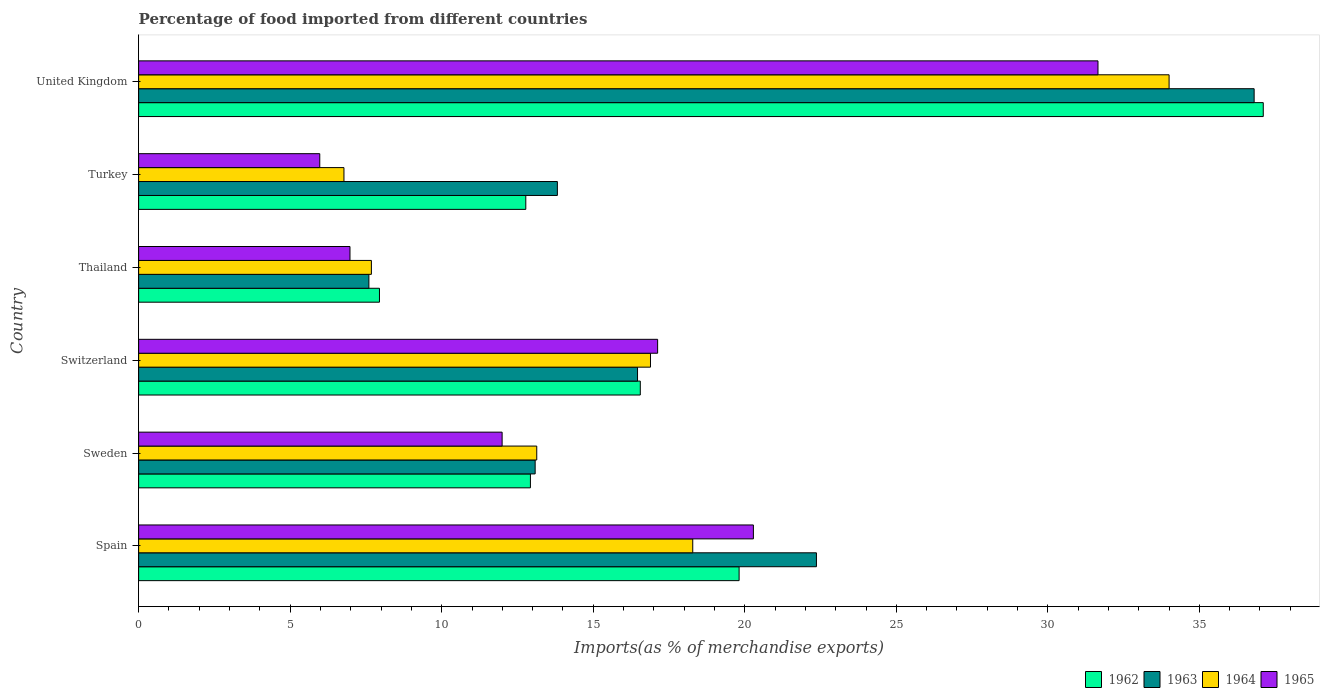How many groups of bars are there?
Your answer should be very brief. 6. Are the number of bars per tick equal to the number of legend labels?
Provide a short and direct response. Yes. Are the number of bars on each tick of the Y-axis equal?
Give a very brief answer. Yes. How many bars are there on the 1st tick from the top?
Give a very brief answer. 4. How many bars are there on the 5th tick from the bottom?
Ensure brevity in your answer.  4. What is the label of the 4th group of bars from the top?
Keep it short and to the point. Switzerland. What is the percentage of imports to different countries in 1962 in Switzerland?
Offer a terse response. 16.55. Across all countries, what is the maximum percentage of imports to different countries in 1962?
Provide a short and direct response. 37.11. Across all countries, what is the minimum percentage of imports to different countries in 1965?
Your answer should be very brief. 5.98. In which country was the percentage of imports to different countries in 1962 minimum?
Your answer should be compact. Thailand. What is the total percentage of imports to different countries in 1964 in the graph?
Offer a terse response. 96.76. What is the difference between the percentage of imports to different countries in 1964 in Switzerland and that in Thailand?
Your response must be concise. 9.21. What is the difference between the percentage of imports to different countries in 1964 in Sweden and the percentage of imports to different countries in 1963 in Spain?
Offer a terse response. -9.23. What is the average percentage of imports to different countries in 1964 per country?
Your answer should be very brief. 16.13. What is the difference between the percentage of imports to different countries in 1965 and percentage of imports to different countries in 1964 in Spain?
Offer a terse response. 2. In how many countries, is the percentage of imports to different countries in 1965 greater than 3 %?
Your response must be concise. 6. What is the ratio of the percentage of imports to different countries in 1962 in Switzerland to that in United Kingdom?
Make the answer very short. 0.45. Is the percentage of imports to different countries in 1963 in Thailand less than that in Turkey?
Give a very brief answer. Yes. What is the difference between the highest and the second highest percentage of imports to different countries in 1963?
Offer a terse response. 14.44. What is the difference between the highest and the lowest percentage of imports to different countries in 1962?
Make the answer very short. 29.16. In how many countries, is the percentage of imports to different countries in 1964 greater than the average percentage of imports to different countries in 1964 taken over all countries?
Your response must be concise. 3. Is the sum of the percentage of imports to different countries in 1965 in Spain and Switzerland greater than the maximum percentage of imports to different countries in 1962 across all countries?
Make the answer very short. Yes. What does the 1st bar from the top in Switzerland represents?
Make the answer very short. 1965. What does the 2nd bar from the bottom in Sweden represents?
Your answer should be very brief. 1963. Is it the case that in every country, the sum of the percentage of imports to different countries in 1964 and percentage of imports to different countries in 1963 is greater than the percentage of imports to different countries in 1965?
Offer a very short reply. Yes. Are the values on the major ticks of X-axis written in scientific E-notation?
Ensure brevity in your answer.  No. Does the graph contain any zero values?
Make the answer very short. No. Where does the legend appear in the graph?
Give a very brief answer. Bottom right. How many legend labels are there?
Offer a terse response. 4. What is the title of the graph?
Your answer should be compact. Percentage of food imported from different countries. Does "1973" appear as one of the legend labels in the graph?
Give a very brief answer. No. What is the label or title of the X-axis?
Provide a short and direct response. Imports(as % of merchandise exports). What is the label or title of the Y-axis?
Give a very brief answer. Country. What is the Imports(as % of merchandise exports) of 1962 in Spain?
Your response must be concise. 19.81. What is the Imports(as % of merchandise exports) in 1963 in Spain?
Your answer should be compact. 22.36. What is the Imports(as % of merchandise exports) in 1964 in Spain?
Your response must be concise. 18.28. What is the Imports(as % of merchandise exports) of 1965 in Spain?
Offer a terse response. 20.28. What is the Imports(as % of merchandise exports) in 1962 in Sweden?
Offer a terse response. 12.93. What is the Imports(as % of merchandise exports) in 1963 in Sweden?
Ensure brevity in your answer.  13.08. What is the Imports(as % of merchandise exports) of 1964 in Sweden?
Provide a short and direct response. 13.14. What is the Imports(as % of merchandise exports) in 1965 in Sweden?
Make the answer very short. 11.99. What is the Imports(as % of merchandise exports) in 1962 in Switzerland?
Ensure brevity in your answer.  16.55. What is the Imports(as % of merchandise exports) in 1963 in Switzerland?
Keep it short and to the point. 16.46. What is the Imports(as % of merchandise exports) in 1964 in Switzerland?
Your answer should be very brief. 16.89. What is the Imports(as % of merchandise exports) of 1965 in Switzerland?
Your answer should be compact. 17.12. What is the Imports(as % of merchandise exports) of 1962 in Thailand?
Provide a short and direct response. 7.95. What is the Imports(as % of merchandise exports) of 1963 in Thailand?
Your response must be concise. 7.6. What is the Imports(as % of merchandise exports) of 1964 in Thailand?
Give a very brief answer. 7.68. What is the Imports(as % of merchandise exports) in 1965 in Thailand?
Ensure brevity in your answer.  6.97. What is the Imports(as % of merchandise exports) of 1962 in Turkey?
Give a very brief answer. 12.77. What is the Imports(as % of merchandise exports) of 1963 in Turkey?
Offer a very short reply. 13.82. What is the Imports(as % of merchandise exports) of 1964 in Turkey?
Offer a very short reply. 6.77. What is the Imports(as % of merchandise exports) of 1965 in Turkey?
Make the answer very short. 5.98. What is the Imports(as % of merchandise exports) in 1962 in United Kingdom?
Offer a terse response. 37.11. What is the Imports(as % of merchandise exports) in 1963 in United Kingdom?
Offer a very short reply. 36.81. What is the Imports(as % of merchandise exports) in 1964 in United Kingdom?
Your answer should be compact. 34. What is the Imports(as % of merchandise exports) in 1965 in United Kingdom?
Offer a terse response. 31.65. Across all countries, what is the maximum Imports(as % of merchandise exports) of 1962?
Your response must be concise. 37.11. Across all countries, what is the maximum Imports(as % of merchandise exports) of 1963?
Provide a short and direct response. 36.81. Across all countries, what is the maximum Imports(as % of merchandise exports) of 1964?
Offer a terse response. 34. Across all countries, what is the maximum Imports(as % of merchandise exports) in 1965?
Provide a succinct answer. 31.65. Across all countries, what is the minimum Imports(as % of merchandise exports) of 1962?
Provide a succinct answer. 7.95. Across all countries, what is the minimum Imports(as % of merchandise exports) of 1963?
Give a very brief answer. 7.6. Across all countries, what is the minimum Imports(as % of merchandise exports) of 1964?
Make the answer very short. 6.77. Across all countries, what is the minimum Imports(as % of merchandise exports) of 1965?
Offer a terse response. 5.98. What is the total Imports(as % of merchandise exports) of 1962 in the graph?
Provide a succinct answer. 107.12. What is the total Imports(as % of merchandise exports) in 1963 in the graph?
Your answer should be very brief. 110.13. What is the total Imports(as % of merchandise exports) of 1964 in the graph?
Your answer should be very brief. 96.76. What is the total Imports(as % of merchandise exports) of 1965 in the graph?
Your response must be concise. 94.01. What is the difference between the Imports(as % of merchandise exports) of 1962 in Spain and that in Sweden?
Give a very brief answer. 6.89. What is the difference between the Imports(as % of merchandise exports) in 1963 in Spain and that in Sweden?
Give a very brief answer. 9.28. What is the difference between the Imports(as % of merchandise exports) in 1964 in Spain and that in Sweden?
Give a very brief answer. 5.15. What is the difference between the Imports(as % of merchandise exports) in 1965 in Spain and that in Sweden?
Give a very brief answer. 8.29. What is the difference between the Imports(as % of merchandise exports) of 1962 in Spain and that in Switzerland?
Offer a terse response. 3.26. What is the difference between the Imports(as % of merchandise exports) in 1963 in Spain and that in Switzerland?
Keep it short and to the point. 5.9. What is the difference between the Imports(as % of merchandise exports) of 1964 in Spain and that in Switzerland?
Give a very brief answer. 1.39. What is the difference between the Imports(as % of merchandise exports) of 1965 in Spain and that in Switzerland?
Offer a very short reply. 3.16. What is the difference between the Imports(as % of merchandise exports) in 1962 in Spain and that in Thailand?
Your answer should be compact. 11.87. What is the difference between the Imports(as % of merchandise exports) of 1963 in Spain and that in Thailand?
Make the answer very short. 14.77. What is the difference between the Imports(as % of merchandise exports) of 1964 in Spain and that in Thailand?
Ensure brevity in your answer.  10.6. What is the difference between the Imports(as % of merchandise exports) in 1965 in Spain and that in Thailand?
Provide a short and direct response. 13.31. What is the difference between the Imports(as % of merchandise exports) of 1962 in Spain and that in Turkey?
Keep it short and to the point. 7.04. What is the difference between the Imports(as % of merchandise exports) in 1963 in Spain and that in Turkey?
Provide a short and direct response. 8.55. What is the difference between the Imports(as % of merchandise exports) of 1964 in Spain and that in Turkey?
Provide a short and direct response. 11.51. What is the difference between the Imports(as % of merchandise exports) in 1965 in Spain and that in Turkey?
Provide a short and direct response. 14.31. What is the difference between the Imports(as % of merchandise exports) in 1962 in Spain and that in United Kingdom?
Your answer should be very brief. -17.29. What is the difference between the Imports(as % of merchandise exports) in 1963 in Spain and that in United Kingdom?
Provide a succinct answer. -14.44. What is the difference between the Imports(as % of merchandise exports) in 1964 in Spain and that in United Kingdom?
Your answer should be very brief. -15.72. What is the difference between the Imports(as % of merchandise exports) of 1965 in Spain and that in United Kingdom?
Your answer should be compact. -11.37. What is the difference between the Imports(as % of merchandise exports) in 1962 in Sweden and that in Switzerland?
Offer a terse response. -3.63. What is the difference between the Imports(as % of merchandise exports) of 1963 in Sweden and that in Switzerland?
Your answer should be compact. -3.38. What is the difference between the Imports(as % of merchandise exports) of 1964 in Sweden and that in Switzerland?
Provide a short and direct response. -3.75. What is the difference between the Imports(as % of merchandise exports) of 1965 in Sweden and that in Switzerland?
Give a very brief answer. -5.13. What is the difference between the Imports(as % of merchandise exports) of 1962 in Sweden and that in Thailand?
Your response must be concise. 4.98. What is the difference between the Imports(as % of merchandise exports) in 1963 in Sweden and that in Thailand?
Keep it short and to the point. 5.49. What is the difference between the Imports(as % of merchandise exports) in 1964 in Sweden and that in Thailand?
Keep it short and to the point. 5.46. What is the difference between the Imports(as % of merchandise exports) in 1965 in Sweden and that in Thailand?
Make the answer very short. 5.02. What is the difference between the Imports(as % of merchandise exports) in 1962 in Sweden and that in Turkey?
Keep it short and to the point. 0.15. What is the difference between the Imports(as % of merchandise exports) of 1963 in Sweden and that in Turkey?
Provide a succinct answer. -0.73. What is the difference between the Imports(as % of merchandise exports) of 1964 in Sweden and that in Turkey?
Offer a very short reply. 6.36. What is the difference between the Imports(as % of merchandise exports) in 1965 in Sweden and that in Turkey?
Give a very brief answer. 6.02. What is the difference between the Imports(as % of merchandise exports) of 1962 in Sweden and that in United Kingdom?
Make the answer very short. -24.18. What is the difference between the Imports(as % of merchandise exports) in 1963 in Sweden and that in United Kingdom?
Your answer should be very brief. -23.72. What is the difference between the Imports(as % of merchandise exports) in 1964 in Sweden and that in United Kingdom?
Provide a succinct answer. -20.86. What is the difference between the Imports(as % of merchandise exports) in 1965 in Sweden and that in United Kingdom?
Ensure brevity in your answer.  -19.66. What is the difference between the Imports(as % of merchandise exports) in 1962 in Switzerland and that in Thailand?
Your answer should be compact. 8.61. What is the difference between the Imports(as % of merchandise exports) of 1963 in Switzerland and that in Thailand?
Your answer should be compact. 8.86. What is the difference between the Imports(as % of merchandise exports) in 1964 in Switzerland and that in Thailand?
Your answer should be compact. 9.21. What is the difference between the Imports(as % of merchandise exports) of 1965 in Switzerland and that in Thailand?
Your answer should be compact. 10.15. What is the difference between the Imports(as % of merchandise exports) in 1962 in Switzerland and that in Turkey?
Make the answer very short. 3.78. What is the difference between the Imports(as % of merchandise exports) of 1963 in Switzerland and that in Turkey?
Provide a succinct answer. 2.64. What is the difference between the Imports(as % of merchandise exports) in 1964 in Switzerland and that in Turkey?
Provide a succinct answer. 10.11. What is the difference between the Imports(as % of merchandise exports) in 1965 in Switzerland and that in Turkey?
Offer a very short reply. 11.15. What is the difference between the Imports(as % of merchandise exports) in 1962 in Switzerland and that in United Kingdom?
Make the answer very short. -20.56. What is the difference between the Imports(as % of merchandise exports) in 1963 in Switzerland and that in United Kingdom?
Offer a very short reply. -20.35. What is the difference between the Imports(as % of merchandise exports) of 1964 in Switzerland and that in United Kingdom?
Give a very brief answer. -17.11. What is the difference between the Imports(as % of merchandise exports) of 1965 in Switzerland and that in United Kingdom?
Offer a very short reply. -14.53. What is the difference between the Imports(as % of merchandise exports) in 1962 in Thailand and that in Turkey?
Keep it short and to the point. -4.83. What is the difference between the Imports(as % of merchandise exports) in 1963 in Thailand and that in Turkey?
Your answer should be compact. -6.22. What is the difference between the Imports(as % of merchandise exports) of 1964 in Thailand and that in Turkey?
Offer a very short reply. 0.91. What is the difference between the Imports(as % of merchandise exports) in 1965 in Thailand and that in Turkey?
Give a very brief answer. 1. What is the difference between the Imports(as % of merchandise exports) in 1962 in Thailand and that in United Kingdom?
Offer a very short reply. -29.16. What is the difference between the Imports(as % of merchandise exports) in 1963 in Thailand and that in United Kingdom?
Offer a terse response. -29.21. What is the difference between the Imports(as % of merchandise exports) of 1964 in Thailand and that in United Kingdom?
Your answer should be compact. -26.32. What is the difference between the Imports(as % of merchandise exports) in 1965 in Thailand and that in United Kingdom?
Keep it short and to the point. -24.68. What is the difference between the Imports(as % of merchandise exports) in 1962 in Turkey and that in United Kingdom?
Provide a short and direct response. -24.33. What is the difference between the Imports(as % of merchandise exports) in 1963 in Turkey and that in United Kingdom?
Your response must be concise. -22.99. What is the difference between the Imports(as % of merchandise exports) of 1964 in Turkey and that in United Kingdom?
Your answer should be compact. -27.23. What is the difference between the Imports(as % of merchandise exports) in 1965 in Turkey and that in United Kingdom?
Offer a very short reply. -25.68. What is the difference between the Imports(as % of merchandise exports) in 1962 in Spain and the Imports(as % of merchandise exports) in 1963 in Sweden?
Your answer should be compact. 6.73. What is the difference between the Imports(as % of merchandise exports) in 1962 in Spain and the Imports(as % of merchandise exports) in 1964 in Sweden?
Ensure brevity in your answer.  6.68. What is the difference between the Imports(as % of merchandise exports) of 1962 in Spain and the Imports(as % of merchandise exports) of 1965 in Sweden?
Your answer should be compact. 7.82. What is the difference between the Imports(as % of merchandise exports) of 1963 in Spain and the Imports(as % of merchandise exports) of 1964 in Sweden?
Provide a short and direct response. 9.23. What is the difference between the Imports(as % of merchandise exports) in 1963 in Spain and the Imports(as % of merchandise exports) in 1965 in Sweden?
Your response must be concise. 10.37. What is the difference between the Imports(as % of merchandise exports) of 1964 in Spain and the Imports(as % of merchandise exports) of 1965 in Sweden?
Give a very brief answer. 6.29. What is the difference between the Imports(as % of merchandise exports) of 1962 in Spain and the Imports(as % of merchandise exports) of 1963 in Switzerland?
Offer a very short reply. 3.35. What is the difference between the Imports(as % of merchandise exports) in 1962 in Spain and the Imports(as % of merchandise exports) in 1964 in Switzerland?
Keep it short and to the point. 2.92. What is the difference between the Imports(as % of merchandise exports) of 1962 in Spain and the Imports(as % of merchandise exports) of 1965 in Switzerland?
Your answer should be compact. 2.69. What is the difference between the Imports(as % of merchandise exports) in 1963 in Spain and the Imports(as % of merchandise exports) in 1964 in Switzerland?
Your answer should be compact. 5.48. What is the difference between the Imports(as % of merchandise exports) of 1963 in Spain and the Imports(as % of merchandise exports) of 1965 in Switzerland?
Your response must be concise. 5.24. What is the difference between the Imports(as % of merchandise exports) of 1964 in Spain and the Imports(as % of merchandise exports) of 1965 in Switzerland?
Ensure brevity in your answer.  1.16. What is the difference between the Imports(as % of merchandise exports) of 1962 in Spain and the Imports(as % of merchandise exports) of 1963 in Thailand?
Offer a terse response. 12.22. What is the difference between the Imports(as % of merchandise exports) of 1962 in Spain and the Imports(as % of merchandise exports) of 1964 in Thailand?
Ensure brevity in your answer.  12.13. What is the difference between the Imports(as % of merchandise exports) in 1962 in Spain and the Imports(as % of merchandise exports) in 1965 in Thailand?
Provide a short and direct response. 12.84. What is the difference between the Imports(as % of merchandise exports) of 1963 in Spain and the Imports(as % of merchandise exports) of 1964 in Thailand?
Your answer should be very brief. 14.68. What is the difference between the Imports(as % of merchandise exports) of 1963 in Spain and the Imports(as % of merchandise exports) of 1965 in Thailand?
Provide a short and direct response. 15.39. What is the difference between the Imports(as % of merchandise exports) of 1964 in Spain and the Imports(as % of merchandise exports) of 1965 in Thailand?
Offer a very short reply. 11.31. What is the difference between the Imports(as % of merchandise exports) in 1962 in Spain and the Imports(as % of merchandise exports) in 1963 in Turkey?
Provide a succinct answer. 6. What is the difference between the Imports(as % of merchandise exports) in 1962 in Spain and the Imports(as % of merchandise exports) in 1964 in Turkey?
Ensure brevity in your answer.  13.04. What is the difference between the Imports(as % of merchandise exports) of 1962 in Spain and the Imports(as % of merchandise exports) of 1965 in Turkey?
Your response must be concise. 13.84. What is the difference between the Imports(as % of merchandise exports) of 1963 in Spain and the Imports(as % of merchandise exports) of 1964 in Turkey?
Give a very brief answer. 15.59. What is the difference between the Imports(as % of merchandise exports) of 1963 in Spain and the Imports(as % of merchandise exports) of 1965 in Turkey?
Provide a succinct answer. 16.39. What is the difference between the Imports(as % of merchandise exports) of 1964 in Spain and the Imports(as % of merchandise exports) of 1965 in Turkey?
Your answer should be compact. 12.31. What is the difference between the Imports(as % of merchandise exports) of 1962 in Spain and the Imports(as % of merchandise exports) of 1963 in United Kingdom?
Provide a succinct answer. -16.99. What is the difference between the Imports(as % of merchandise exports) in 1962 in Spain and the Imports(as % of merchandise exports) in 1964 in United Kingdom?
Offer a very short reply. -14.19. What is the difference between the Imports(as % of merchandise exports) in 1962 in Spain and the Imports(as % of merchandise exports) in 1965 in United Kingdom?
Offer a very short reply. -11.84. What is the difference between the Imports(as % of merchandise exports) in 1963 in Spain and the Imports(as % of merchandise exports) in 1964 in United Kingdom?
Offer a very short reply. -11.64. What is the difference between the Imports(as % of merchandise exports) of 1963 in Spain and the Imports(as % of merchandise exports) of 1965 in United Kingdom?
Give a very brief answer. -9.29. What is the difference between the Imports(as % of merchandise exports) in 1964 in Spain and the Imports(as % of merchandise exports) in 1965 in United Kingdom?
Your answer should be compact. -13.37. What is the difference between the Imports(as % of merchandise exports) of 1962 in Sweden and the Imports(as % of merchandise exports) of 1963 in Switzerland?
Your answer should be compact. -3.53. What is the difference between the Imports(as % of merchandise exports) in 1962 in Sweden and the Imports(as % of merchandise exports) in 1964 in Switzerland?
Keep it short and to the point. -3.96. What is the difference between the Imports(as % of merchandise exports) of 1962 in Sweden and the Imports(as % of merchandise exports) of 1965 in Switzerland?
Offer a very short reply. -4.2. What is the difference between the Imports(as % of merchandise exports) of 1963 in Sweden and the Imports(as % of merchandise exports) of 1964 in Switzerland?
Provide a succinct answer. -3.81. What is the difference between the Imports(as % of merchandise exports) of 1963 in Sweden and the Imports(as % of merchandise exports) of 1965 in Switzerland?
Give a very brief answer. -4.04. What is the difference between the Imports(as % of merchandise exports) of 1964 in Sweden and the Imports(as % of merchandise exports) of 1965 in Switzerland?
Offer a terse response. -3.99. What is the difference between the Imports(as % of merchandise exports) of 1962 in Sweden and the Imports(as % of merchandise exports) of 1963 in Thailand?
Provide a succinct answer. 5.33. What is the difference between the Imports(as % of merchandise exports) in 1962 in Sweden and the Imports(as % of merchandise exports) in 1964 in Thailand?
Offer a terse response. 5.25. What is the difference between the Imports(as % of merchandise exports) in 1962 in Sweden and the Imports(as % of merchandise exports) in 1965 in Thailand?
Give a very brief answer. 5.95. What is the difference between the Imports(as % of merchandise exports) of 1963 in Sweden and the Imports(as % of merchandise exports) of 1964 in Thailand?
Provide a succinct answer. 5.4. What is the difference between the Imports(as % of merchandise exports) in 1963 in Sweden and the Imports(as % of merchandise exports) in 1965 in Thailand?
Ensure brevity in your answer.  6.11. What is the difference between the Imports(as % of merchandise exports) of 1964 in Sweden and the Imports(as % of merchandise exports) of 1965 in Thailand?
Your response must be concise. 6.16. What is the difference between the Imports(as % of merchandise exports) of 1962 in Sweden and the Imports(as % of merchandise exports) of 1963 in Turkey?
Provide a succinct answer. -0.89. What is the difference between the Imports(as % of merchandise exports) in 1962 in Sweden and the Imports(as % of merchandise exports) in 1964 in Turkey?
Give a very brief answer. 6.15. What is the difference between the Imports(as % of merchandise exports) of 1962 in Sweden and the Imports(as % of merchandise exports) of 1965 in Turkey?
Keep it short and to the point. 6.95. What is the difference between the Imports(as % of merchandise exports) in 1963 in Sweden and the Imports(as % of merchandise exports) in 1964 in Turkey?
Your answer should be compact. 6.31. What is the difference between the Imports(as % of merchandise exports) of 1963 in Sweden and the Imports(as % of merchandise exports) of 1965 in Turkey?
Your answer should be very brief. 7.11. What is the difference between the Imports(as % of merchandise exports) of 1964 in Sweden and the Imports(as % of merchandise exports) of 1965 in Turkey?
Provide a succinct answer. 7.16. What is the difference between the Imports(as % of merchandise exports) of 1962 in Sweden and the Imports(as % of merchandise exports) of 1963 in United Kingdom?
Your answer should be compact. -23.88. What is the difference between the Imports(as % of merchandise exports) of 1962 in Sweden and the Imports(as % of merchandise exports) of 1964 in United Kingdom?
Ensure brevity in your answer.  -21.07. What is the difference between the Imports(as % of merchandise exports) of 1962 in Sweden and the Imports(as % of merchandise exports) of 1965 in United Kingdom?
Provide a succinct answer. -18.73. What is the difference between the Imports(as % of merchandise exports) of 1963 in Sweden and the Imports(as % of merchandise exports) of 1964 in United Kingdom?
Your response must be concise. -20.92. What is the difference between the Imports(as % of merchandise exports) in 1963 in Sweden and the Imports(as % of merchandise exports) in 1965 in United Kingdom?
Ensure brevity in your answer.  -18.57. What is the difference between the Imports(as % of merchandise exports) in 1964 in Sweden and the Imports(as % of merchandise exports) in 1965 in United Kingdom?
Provide a succinct answer. -18.52. What is the difference between the Imports(as % of merchandise exports) in 1962 in Switzerland and the Imports(as % of merchandise exports) in 1963 in Thailand?
Your response must be concise. 8.96. What is the difference between the Imports(as % of merchandise exports) of 1962 in Switzerland and the Imports(as % of merchandise exports) of 1964 in Thailand?
Your answer should be very brief. 8.87. What is the difference between the Imports(as % of merchandise exports) of 1962 in Switzerland and the Imports(as % of merchandise exports) of 1965 in Thailand?
Your answer should be compact. 9.58. What is the difference between the Imports(as % of merchandise exports) of 1963 in Switzerland and the Imports(as % of merchandise exports) of 1964 in Thailand?
Your answer should be compact. 8.78. What is the difference between the Imports(as % of merchandise exports) in 1963 in Switzerland and the Imports(as % of merchandise exports) in 1965 in Thailand?
Offer a terse response. 9.49. What is the difference between the Imports(as % of merchandise exports) in 1964 in Switzerland and the Imports(as % of merchandise exports) in 1965 in Thailand?
Ensure brevity in your answer.  9.92. What is the difference between the Imports(as % of merchandise exports) of 1962 in Switzerland and the Imports(as % of merchandise exports) of 1963 in Turkey?
Offer a terse response. 2.74. What is the difference between the Imports(as % of merchandise exports) in 1962 in Switzerland and the Imports(as % of merchandise exports) in 1964 in Turkey?
Offer a very short reply. 9.78. What is the difference between the Imports(as % of merchandise exports) in 1962 in Switzerland and the Imports(as % of merchandise exports) in 1965 in Turkey?
Provide a succinct answer. 10.58. What is the difference between the Imports(as % of merchandise exports) in 1963 in Switzerland and the Imports(as % of merchandise exports) in 1964 in Turkey?
Make the answer very short. 9.69. What is the difference between the Imports(as % of merchandise exports) in 1963 in Switzerland and the Imports(as % of merchandise exports) in 1965 in Turkey?
Your response must be concise. 10.48. What is the difference between the Imports(as % of merchandise exports) of 1964 in Switzerland and the Imports(as % of merchandise exports) of 1965 in Turkey?
Provide a short and direct response. 10.91. What is the difference between the Imports(as % of merchandise exports) in 1962 in Switzerland and the Imports(as % of merchandise exports) in 1963 in United Kingdom?
Make the answer very short. -20.25. What is the difference between the Imports(as % of merchandise exports) in 1962 in Switzerland and the Imports(as % of merchandise exports) in 1964 in United Kingdom?
Ensure brevity in your answer.  -17.45. What is the difference between the Imports(as % of merchandise exports) in 1962 in Switzerland and the Imports(as % of merchandise exports) in 1965 in United Kingdom?
Your answer should be very brief. -15.1. What is the difference between the Imports(as % of merchandise exports) of 1963 in Switzerland and the Imports(as % of merchandise exports) of 1964 in United Kingdom?
Make the answer very short. -17.54. What is the difference between the Imports(as % of merchandise exports) in 1963 in Switzerland and the Imports(as % of merchandise exports) in 1965 in United Kingdom?
Provide a short and direct response. -15.19. What is the difference between the Imports(as % of merchandise exports) of 1964 in Switzerland and the Imports(as % of merchandise exports) of 1965 in United Kingdom?
Your answer should be very brief. -14.77. What is the difference between the Imports(as % of merchandise exports) of 1962 in Thailand and the Imports(as % of merchandise exports) of 1963 in Turkey?
Your response must be concise. -5.87. What is the difference between the Imports(as % of merchandise exports) of 1962 in Thailand and the Imports(as % of merchandise exports) of 1964 in Turkey?
Your response must be concise. 1.17. What is the difference between the Imports(as % of merchandise exports) of 1962 in Thailand and the Imports(as % of merchandise exports) of 1965 in Turkey?
Ensure brevity in your answer.  1.97. What is the difference between the Imports(as % of merchandise exports) in 1963 in Thailand and the Imports(as % of merchandise exports) in 1964 in Turkey?
Provide a short and direct response. 0.82. What is the difference between the Imports(as % of merchandise exports) of 1963 in Thailand and the Imports(as % of merchandise exports) of 1965 in Turkey?
Your answer should be very brief. 1.62. What is the difference between the Imports(as % of merchandise exports) in 1964 in Thailand and the Imports(as % of merchandise exports) in 1965 in Turkey?
Ensure brevity in your answer.  1.7. What is the difference between the Imports(as % of merchandise exports) in 1962 in Thailand and the Imports(as % of merchandise exports) in 1963 in United Kingdom?
Your answer should be very brief. -28.86. What is the difference between the Imports(as % of merchandise exports) of 1962 in Thailand and the Imports(as % of merchandise exports) of 1964 in United Kingdom?
Your response must be concise. -26.05. What is the difference between the Imports(as % of merchandise exports) in 1962 in Thailand and the Imports(as % of merchandise exports) in 1965 in United Kingdom?
Provide a succinct answer. -23.71. What is the difference between the Imports(as % of merchandise exports) in 1963 in Thailand and the Imports(as % of merchandise exports) in 1964 in United Kingdom?
Give a very brief answer. -26.4. What is the difference between the Imports(as % of merchandise exports) of 1963 in Thailand and the Imports(as % of merchandise exports) of 1965 in United Kingdom?
Keep it short and to the point. -24.06. What is the difference between the Imports(as % of merchandise exports) of 1964 in Thailand and the Imports(as % of merchandise exports) of 1965 in United Kingdom?
Offer a very short reply. -23.97. What is the difference between the Imports(as % of merchandise exports) of 1962 in Turkey and the Imports(as % of merchandise exports) of 1963 in United Kingdom?
Ensure brevity in your answer.  -24.03. What is the difference between the Imports(as % of merchandise exports) in 1962 in Turkey and the Imports(as % of merchandise exports) in 1964 in United Kingdom?
Provide a short and direct response. -21.23. What is the difference between the Imports(as % of merchandise exports) of 1962 in Turkey and the Imports(as % of merchandise exports) of 1965 in United Kingdom?
Make the answer very short. -18.88. What is the difference between the Imports(as % of merchandise exports) of 1963 in Turkey and the Imports(as % of merchandise exports) of 1964 in United Kingdom?
Ensure brevity in your answer.  -20.18. What is the difference between the Imports(as % of merchandise exports) of 1963 in Turkey and the Imports(as % of merchandise exports) of 1965 in United Kingdom?
Provide a succinct answer. -17.84. What is the difference between the Imports(as % of merchandise exports) of 1964 in Turkey and the Imports(as % of merchandise exports) of 1965 in United Kingdom?
Make the answer very short. -24.88. What is the average Imports(as % of merchandise exports) of 1962 per country?
Make the answer very short. 17.85. What is the average Imports(as % of merchandise exports) in 1963 per country?
Offer a very short reply. 18.36. What is the average Imports(as % of merchandise exports) in 1964 per country?
Offer a very short reply. 16.13. What is the average Imports(as % of merchandise exports) in 1965 per country?
Keep it short and to the point. 15.67. What is the difference between the Imports(as % of merchandise exports) of 1962 and Imports(as % of merchandise exports) of 1963 in Spain?
Your answer should be very brief. -2.55. What is the difference between the Imports(as % of merchandise exports) in 1962 and Imports(as % of merchandise exports) in 1964 in Spain?
Your response must be concise. 1.53. What is the difference between the Imports(as % of merchandise exports) of 1962 and Imports(as % of merchandise exports) of 1965 in Spain?
Provide a short and direct response. -0.47. What is the difference between the Imports(as % of merchandise exports) of 1963 and Imports(as % of merchandise exports) of 1964 in Spain?
Make the answer very short. 4.08. What is the difference between the Imports(as % of merchandise exports) of 1963 and Imports(as % of merchandise exports) of 1965 in Spain?
Make the answer very short. 2.08. What is the difference between the Imports(as % of merchandise exports) of 1964 and Imports(as % of merchandise exports) of 1965 in Spain?
Offer a very short reply. -2. What is the difference between the Imports(as % of merchandise exports) in 1962 and Imports(as % of merchandise exports) in 1963 in Sweden?
Ensure brevity in your answer.  -0.16. What is the difference between the Imports(as % of merchandise exports) of 1962 and Imports(as % of merchandise exports) of 1964 in Sweden?
Give a very brief answer. -0.21. What is the difference between the Imports(as % of merchandise exports) in 1962 and Imports(as % of merchandise exports) in 1965 in Sweden?
Provide a succinct answer. 0.93. What is the difference between the Imports(as % of merchandise exports) in 1963 and Imports(as % of merchandise exports) in 1964 in Sweden?
Provide a succinct answer. -0.05. What is the difference between the Imports(as % of merchandise exports) in 1963 and Imports(as % of merchandise exports) in 1965 in Sweden?
Your answer should be compact. 1.09. What is the difference between the Imports(as % of merchandise exports) in 1964 and Imports(as % of merchandise exports) in 1965 in Sweden?
Your answer should be compact. 1.14. What is the difference between the Imports(as % of merchandise exports) of 1962 and Imports(as % of merchandise exports) of 1963 in Switzerland?
Provide a short and direct response. 0.09. What is the difference between the Imports(as % of merchandise exports) in 1962 and Imports(as % of merchandise exports) in 1964 in Switzerland?
Ensure brevity in your answer.  -0.34. What is the difference between the Imports(as % of merchandise exports) of 1962 and Imports(as % of merchandise exports) of 1965 in Switzerland?
Ensure brevity in your answer.  -0.57. What is the difference between the Imports(as % of merchandise exports) of 1963 and Imports(as % of merchandise exports) of 1964 in Switzerland?
Your answer should be very brief. -0.43. What is the difference between the Imports(as % of merchandise exports) in 1963 and Imports(as % of merchandise exports) in 1965 in Switzerland?
Provide a short and direct response. -0.66. What is the difference between the Imports(as % of merchandise exports) in 1964 and Imports(as % of merchandise exports) in 1965 in Switzerland?
Provide a short and direct response. -0.24. What is the difference between the Imports(as % of merchandise exports) of 1962 and Imports(as % of merchandise exports) of 1963 in Thailand?
Give a very brief answer. 0.35. What is the difference between the Imports(as % of merchandise exports) in 1962 and Imports(as % of merchandise exports) in 1964 in Thailand?
Provide a short and direct response. 0.27. What is the difference between the Imports(as % of merchandise exports) in 1962 and Imports(as % of merchandise exports) in 1965 in Thailand?
Offer a terse response. 0.97. What is the difference between the Imports(as % of merchandise exports) of 1963 and Imports(as % of merchandise exports) of 1964 in Thailand?
Offer a very short reply. -0.08. What is the difference between the Imports(as % of merchandise exports) of 1963 and Imports(as % of merchandise exports) of 1965 in Thailand?
Give a very brief answer. 0.62. What is the difference between the Imports(as % of merchandise exports) in 1964 and Imports(as % of merchandise exports) in 1965 in Thailand?
Your answer should be compact. 0.71. What is the difference between the Imports(as % of merchandise exports) in 1962 and Imports(as % of merchandise exports) in 1963 in Turkey?
Your response must be concise. -1.04. What is the difference between the Imports(as % of merchandise exports) of 1962 and Imports(as % of merchandise exports) of 1964 in Turkey?
Ensure brevity in your answer.  6. What is the difference between the Imports(as % of merchandise exports) of 1962 and Imports(as % of merchandise exports) of 1965 in Turkey?
Your answer should be very brief. 6.8. What is the difference between the Imports(as % of merchandise exports) of 1963 and Imports(as % of merchandise exports) of 1964 in Turkey?
Your response must be concise. 7.04. What is the difference between the Imports(as % of merchandise exports) in 1963 and Imports(as % of merchandise exports) in 1965 in Turkey?
Ensure brevity in your answer.  7.84. What is the difference between the Imports(as % of merchandise exports) of 1964 and Imports(as % of merchandise exports) of 1965 in Turkey?
Make the answer very short. 0.8. What is the difference between the Imports(as % of merchandise exports) of 1962 and Imports(as % of merchandise exports) of 1963 in United Kingdom?
Your answer should be very brief. 0.3. What is the difference between the Imports(as % of merchandise exports) in 1962 and Imports(as % of merchandise exports) in 1964 in United Kingdom?
Offer a very short reply. 3.11. What is the difference between the Imports(as % of merchandise exports) of 1962 and Imports(as % of merchandise exports) of 1965 in United Kingdom?
Your answer should be very brief. 5.45. What is the difference between the Imports(as % of merchandise exports) of 1963 and Imports(as % of merchandise exports) of 1964 in United Kingdom?
Ensure brevity in your answer.  2.81. What is the difference between the Imports(as % of merchandise exports) of 1963 and Imports(as % of merchandise exports) of 1965 in United Kingdom?
Make the answer very short. 5.15. What is the difference between the Imports(as % of merchandise exports) of 1964 and Imports(as % of merchandise exports) of 1965 in United Kingdom?
Offer a very short reply. 2.35. What is the ratio of the Imports(as % of merchandise exports) in 1962 in Spain to that in Sweden?
Your response must be concise. 1.53. What is the ratio of the Imports(as % of merchandise exports) of 1963 in Spain to that in Sweden?
Keep it short and to the point. 1.71. What is the ratio of the Imports(as % of merchandise exports) in 1964 in Spain to that in Sweden?
Your response must be concise. 1.39. What is the ratio of the Imports(as % of merchandise exports) of 1965 in Spain to that in Sweden?
Provide a short and direct response. 1.69. What is the ratio of the Imports(as % of merchandise exports) of 1962 in Spain to that in Switzerland?
Your answer should be very brief. 1.2. What is the ratio of the Imports(as % of merchandise exports) of 1963 in Spain to that in Switzerland?
Give a very brief answer. 1.36. What is the ratio of the Imports(as % of merchandise exports) in 1964 in Spain to that in Switzerland?
Your answer should be very brief. 1.08. What is the ratio of the Imports(as % of merchandise exports) in 1965 in Spain to that in Switzerland?
Offer a terse response. 1.18. What is the ratio of the Imports(as % of merchandise exports) of 1962 in Spain to that in Thailand?
Your response must be concise. 2.49. What is the ratio of the Imports(as % of merchandise exports) in 1963 in Spain to that in Thailand?
Your answer should be very brief. 2.94. What is the ratio of the Imports(as % of merchandise exports) of 1964 in Spain to that in Thailand?
Ensure brevity in your answer.  2.38. What is the ratio of the Imports(as % of merchandise exports) of 1965 in Spain to that in Thailand?
Give a very brief answer. 2.91. What is the ratio of the Imports(as % of merchandise exports) in 1962 in Spain to that in Turkey?
Offer a terse response. 1.55. What is the ratio of the Imports(as % of merchandise exports) of 1963 in Spain to that in Turkey?
Give a very brief answer. 1.62. What is the ratio of the Imports(as % of merchandise exports) in 1964 in Spain to that in Turkey?
Your answer should be very brief. 2.7. What is the ratio of the Imports(as % of merchandise exports) in 1965 in Spain to that in Turkey?
Keep it short and to the point. 3.39. What is the ratio of the Imports(as % of merchandise exports) of 1962 in Spain to that in United Kingdom?
Make the answer very short. 0.53. What is the ratio of the Imports(as % of merchandise exports) of 1963 in Spain to that in United Kingdom?
Give a very brief answer. 0.61. What is the ratio of the Imports(as % of merchandise exports) of 1964 in Spain to that in United Kingdom?
Your answer should be very brief. 0.54. What is the ratio of the Imports(as % of merchandise exports) in 1965 in Spain to that in United Kingdom?
Your response must be concise. 0.64. What is the ratio of the Imports(as % of merchandise exports) in 1962 in Sweden to that in Switzerland?
Your answer should be compact. 0.78. What is the ratio of the Imports(as % of merchandise exports) of 1963 in Sweden to that in Switzerland?
Offer a terse response. 0.79. What is the ratio of the Imports(as % of merchandise exports) of 1964 in Sweden to that in Switzerland?
Your answer should be very brief. 0.78. What is the ratio of the Imports(as % of merchandise exports) of 1965 in Sweden to that in Switzerland?
Make the answer very short. 0.7. What is the ratio of the Imports(as % of merchandise exports) in 1962 in Sweden to that in Thailand?
Your response must be concise. 1.63. What is the ratio of the Imports(as % of merchandise exports) in 1963 in Sweden to that in Thailand?
Make the answer very short. 1.72. What is the ratio of the Imports(as % of merchandise exports) of 1964 in Sweden to that in Thailand?
Offer a terse response. 1.71. What is the ratio of the Imports(as % of merchandise exports) in 1965 in Sweden to that in Thailand?
Make the answer very short. 1.72. What is the ratio of the Imports(as % of merchandise exports) in 1962 in Sweden to that in Turkey?
Ensure brevity in your answer.  1.01. What is the ratio of the Imports(as % of merchandise exports) in 1963 in Sweden to that in Turkey?
Provide a succinct answer. 0.95. What is the ratio of the Imports(as % of merchandise exports) in 1964 in Sweden to that in Turkey?
Your answer should be compact. 1.94. What is the ratio of the Imports(as % of merchandise exports) of 1965 in Sweden to that in Turkey?
Make the answer very short. 2.01. What is the ratio of the Imports(as % of merchandise exports) in 1962 in Sweden to that in United Kingdom?
Your answer should be compact. 0.35. What is the ratio of the Imports(as % of merchandise exports) in 1963 in Sweden to that in United Kingdom?
Give a very brief answer. 0.36. What is the ratio of the Imports(as % of merchandise exports) of 1964 in Sweden to that in United Kingdom?
Ensure brevity in your answer.  0.39. What is the ratio of the Imports(as % of merchandise exports) of 1965 in Sweden to that in United Kingdom?
Ensure brevity in your answer.  0.38. What is the ratio of the Imports(as % of merchandise exports) of 1962 in Switzerland to that in Thailand?
Provide a short and direct response. 2.08. What is the ratio of the Imports(as % of merchandise exports) of 1963 in Switzerland to that in Thailand?
Your answer should be very brief. 2.17. What is the ratio of the Imports(as % of merchandise exports) of 1964 in Switzerland to that in Thailand?
Your answer should be compact. 2.2. What is the ratio of the Imports(as % of merchandise exports) in 1965 in Switzerland to that in Thailand?
Give a very brief answer. 2.46. What is the ratio of the Imports(as % of merchandise exports) of 1962 in Switzerland to that in Turkey?
Make the answer very short. 1.3. What is the ratio of the Imports(as % of merchandise exports) of 1963 in Switzerland to that in Turkey?
Keep it short and to the point. 1.19. What is the ratio of the Imports(as % of merchandise exports) of 1964 in Switzerland to that in Turkey?
Keep it short and to the point. 2.49. What is the ratio of the Imports(as % of merchandise exports) in 1965 in Switzerland to that in Turkey?
Make the answer very short. 2.87. What is the ratio of the Imports(as % of merchandise exports) of 1962 in Switzerland to that in United Kingdom?
Give a very brief answer. 0.45. What is the ratio of the Imports(as % of merchandise exports) in 1963 in Switzerland to that in United Kingdom?
Give a very brief answer. 0.45. What is the ratio of the Imports(as % of merchandise exports) of 1964 in Switzerland to that in United Kingdom?
Make the answer very short. 0.5. What is the ratio of the Imports(as % of merchandise exports) of 1965 in Switzerland to that in United Kingdom?
Keep it short and to the point. 0.54. What is the ratio of the Imports(as % of merchandise exports) of 1962 in Thailand to that in Turkey?
Your answer should be compact. 0.62. What is the ratio of the Imports(as % of merchandise exports) of 1963 in Thailand to that in Turkey?
Keep it short and to the point. 0.55. What is the ratio of the Imports(as % of merchandise exports) in 1964 in Thailand to that in Turkey?
Keep it short and to the point. 1.13. What is the ratio of the Imports(as % of merchandise exports) in 1965 in Thailand to that in Turkey?
Give a very brief answer. 1.17. What is the ratio of the Imports(as % of merchandise exports) of 1962 in Thailand to that in United Kingdom?
Your answer should be compact. 0.21. What is the ratio of the Imports(as % of merchandise exports) in 1963 in Thailand to that in United Kingdom?
Your answer should be compact. 0.21. What is the ratio of the Imports(as % of merchandise exports) in 1964 in Thailand to that in United Kingdom?
Offer a terse response. 0.23. What is the ratio of the Imports(as % of merchandise exports) in 1965 in Thailand to that in United Kingdom?
Offer a very short reply. 0.22. What is the ratio of the Imports(as % of merchandise exports) of 1962 in Turkey to that in United Kingdom?
Offer a terse response. 0.34. What is the ratio of the Imports(as % of merchandise exports) in 1963 in Turkey to that in United Kingdom?
Provide a short and direct response. 0.38. What is the ratio of the Imports(as % of merchandise exports) in 1964 in Turkey to that in United Kingdom?
Ensure brevity in your answer.  0.2. What is the ratio of the Imports(as % of merchandise exports) in 1965 in Turkey to that in United Kingdom?
Ensure brevity in your answer.  0.19. What is the difference between the highest and the second highest Imports(as % of merchandise exports) of 1962?
Offer a terse response. 17.29. What is the difference between the highest and the second highest Imports(as % of merchandise exports) in 1963?
Provide a succinct answer. 14.44. What is the difference between the highest and the second highest Imports(as % of merchandise exports) in 1964?
Ensure brevity in your answer.  15.72. What is the difference between the highest and the second highest Imports(as % of merchandise exports) of 1965?
Your answer should be very brief. 11.37. What is the difference between the highest and the lowest Imports(as % of merchandise exports) in 1962?
Provide a short and direct response. 29.16. What is the difference between the highest and the lowest Imports(as % of merchandise exports) in 1963?
Keep it short and to the point. 29.21. What is the difference between the highest and the lowest Imports(as % of merchandise exports) of 1964?
Your response must be concise. 27.23. What is the difference between the highest and the lowest Imports(as % of merchandise exports) of 1965?
Make the answer very short. 25.68. 